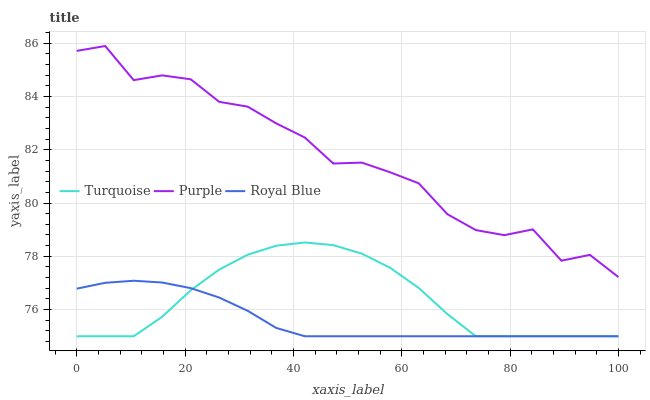Does Royal Blue have the minimum area under the curve?
Answer yes or no. Yes. Does Purple have the maximum area under the curve?
Answer yes or no. Yes. Does Turquoise have the minimum area under the curve?
Answer yes or no. No. Does Turquoise have the maximum area under the curve?
Answer yes or no. No. Is Royal Blue the smoothest?
Answer yes or no. Yes. Is Purple the roughest?
Answer yes or no. Yes. Is Turquoise the smoothest?
Answer yes or no. No. Is Turquoise the roughest?
Answer yes or no. No. Does Royal Blue have the lowest value?
Answer yes or no. Yes. Does Purple have the highest value?
Answer yes or no. Yes. Does Turquoise have the highest value?
Answer yes or no. No. Is Royal Blue less than Purple?
Answer yes or no. Yes. Is Purple greater than Turquoise?
Answer yes or no. Yes. Does Turquoise intersect Royal Blue?
Answer yes or no. Yes. Is Turquoise less than Royal Blue?
Answer yes or no. No. Is Turquoise greater than Royal Blue?
Answer yes or no. No. Does Royal Blue intersect Purple?
Answer yes or no. No. 